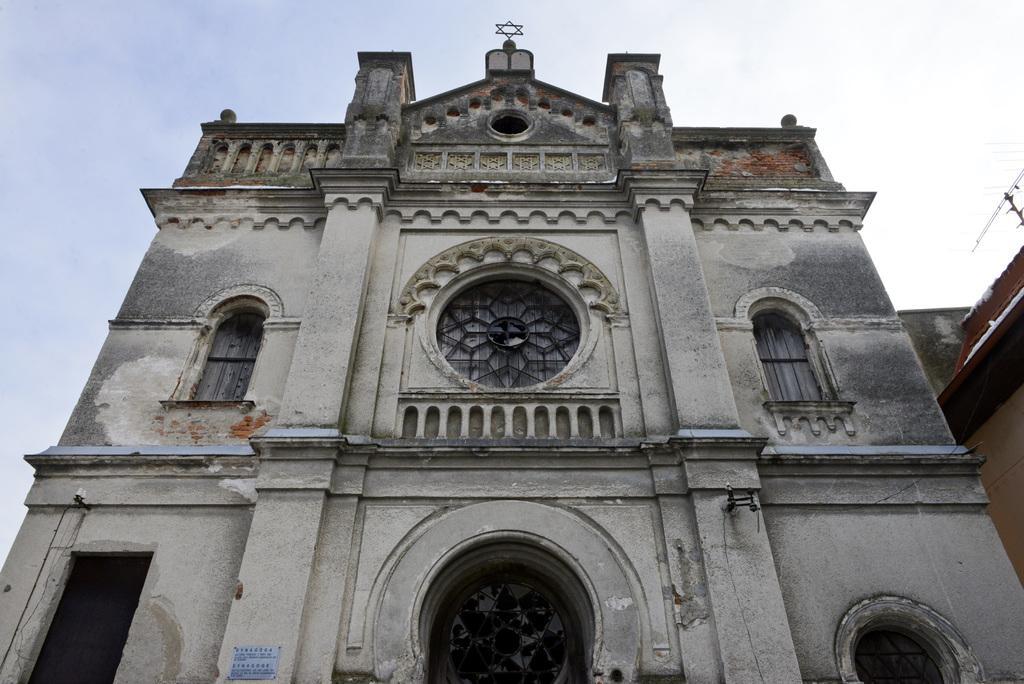How would you summarize this image in a sentence or two? In this image I can see few buildings, windows, the sky, a board and on it I can see something is written. 